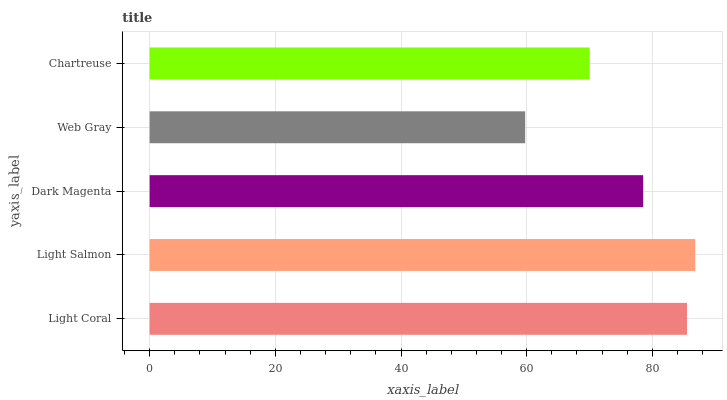Is Web Gray the minimum?
Answer yes or no. Yes. Is Light Salmon the maximum?
Answer yes or no. Yes. Is Dark Magenta the minimum?
Answer yes or no. No. Is Dark Magenta the maximum?
Answer yes or no. No. Is Light Salmon greater than Dark Magenta?
Answer yes or no. Yes. Is Dark Magenta less than Light Salmon?
Answer yes or no. Yes. Is Dark Magenta greater than Light Salmon?
Answer yes or no. No. Is Light Salmon less than Dark Magenta?
Answer yes or no. No. Is Dark Magenta the high median?
Answer yes or no. Yes. Is Dark Magenta the low median?
Answer yes or no. Yes. Is Chartreuse the high median?
Answer yes or no. No. Is Light Coral the low median?
Answer yes or no. No. 